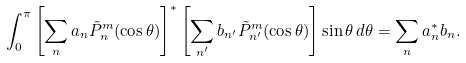Convert formula to latex. <formula><loc_0><loc_0><loc_500><loc_500>\int _ { 0 } ^ { \pi } \left [ \sum _ { n } a _ { n } \tilde { P } ^ { m } _ { n } ( \cos \theta ) \right ] ^ { * } \left [ \sum _ { n ^ { \prime } } b _ { n ^ { \prime } } \tilde { P } ^ { m } _ { n ^ { \prime } } ( \cos \theta ) \right ] \sin \theta \, d \theta = \sum _ { n } a _ { n } ^ { * } b _ { n } .</formula> 